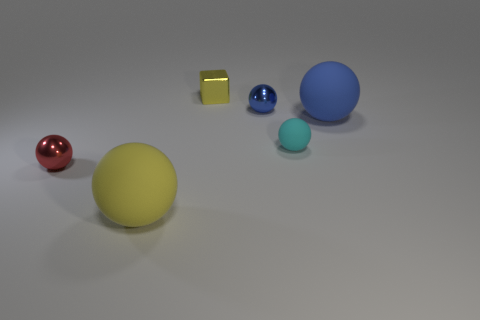Subtract all blue blocks. How many blue balls are left? 2 Subtract all yellow spheres. How many spheres are left? 4 Subtract all small shiny balls. How many balls are left? 3 Add 1 large metallic cylinders. How many objects exist? 7 Subtract all green spheres. Subtract all yellow cylinders. How many spheres are left? 5 Subtract all spheres. How many objects are left? 1 Add 1 blue shiny objects. How many blue shiny objects exist? 2 Subtract 1 yellow balls. How many objects are left? 5 Subtract all large rubber objects. Subtract all tiny blue things. How many objects are left? 3 Add 3 cyan matte balls. How many cyan matte balls are left? 4 